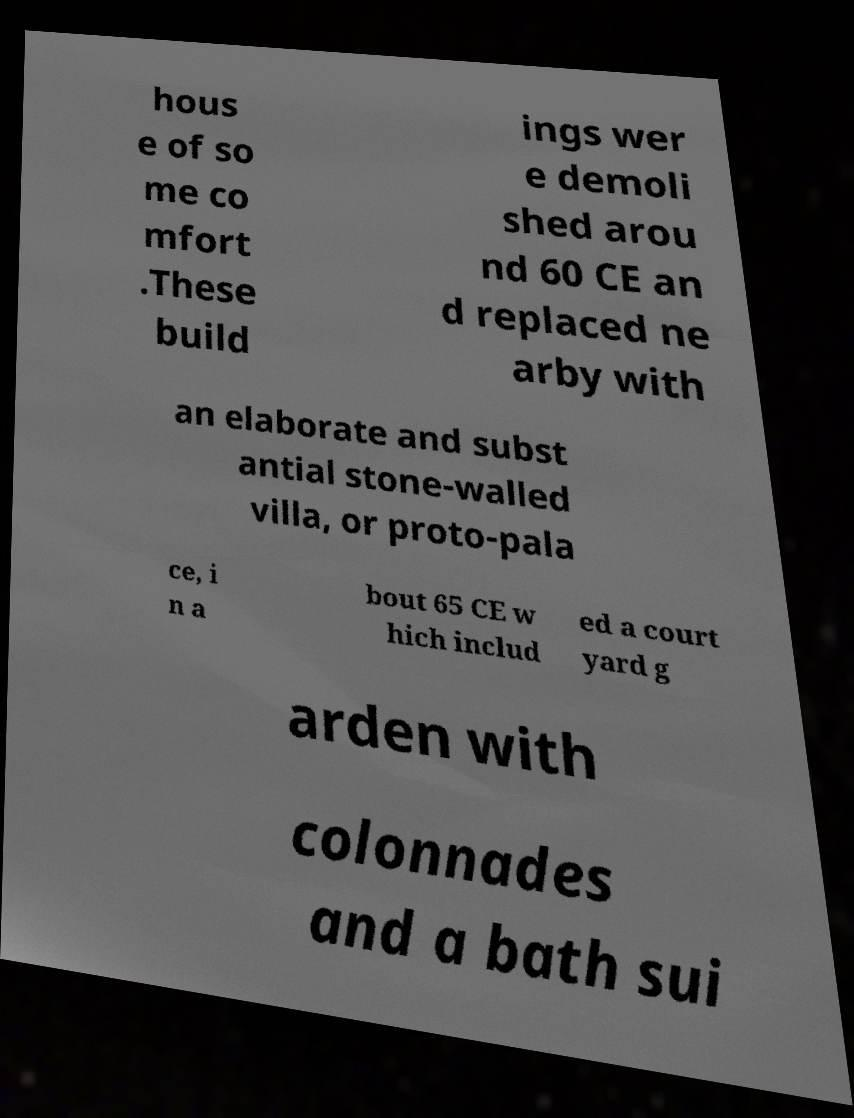Please read and relay the text visible in this image. What does it say? hous e of so me co mfort .These build ings wer e demoli shed arou nd 60 CE an d replaced ne arby with an elaborate and subst antial stone-walled villa, or proto-pala ce, i n a bout 65 CE w hich includ ed a court yard g arden with colonnades and a bath sui 